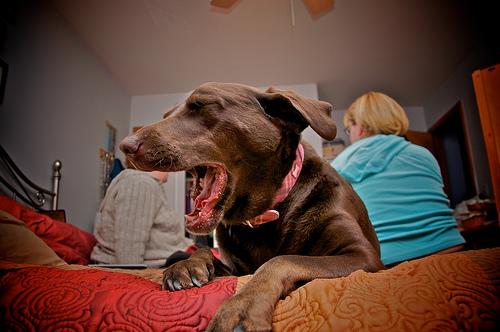What color is the dog's tongue?
Quick response, please. Pink. What color is the color on the dog?
Be succinct. Brown. What color is the dog's collar?
Short answer required. Pink. Is the dog yawning?
Quick response, please. Yes. 